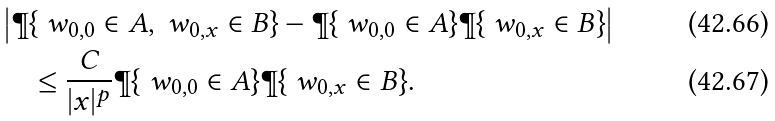<formula> <loc_0><loc_0><loc_500><loc_500>& \left | \P \{ \ w _ { 0 , 0 } \in A , \ w _ { 0 , x } \in B \} - \P \{ \ w _ { 0 , 0 } \in A \} \P \{ \ w _ { 0 , x } \in B \} \right | \\ & \quad \leq \frac { C } { | x | ^ { p } } \P \{ \ w _ { 0 , 0 } \in A \} \P \{ \ w _ { 0 , x } \in B \} .</formula> 